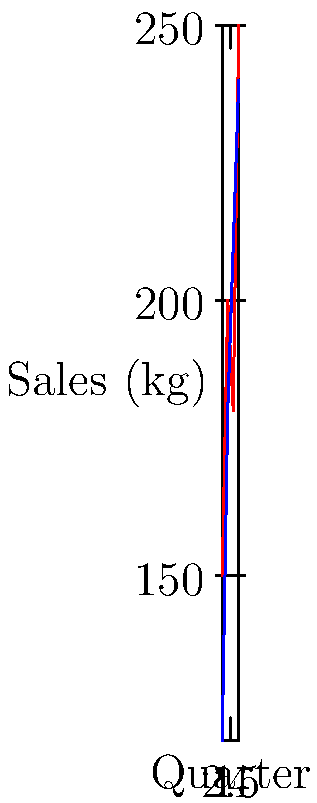Based on the coordinate plane showing quarterly sales data for Arabica and Robusta coffee beans, what is the total increase in sales (in kg) for Arabica beans from Q1 to Q4? To find the total increase in sales for Arabica beans from Q1 to Q4, we need to:

1. Identify the sales figures for Arabica in Q1 and Q4:
   Q1 (x = 1): 150 kg
   Q4 (x = 4): 250 kg

2. Calculate the difference between Q4 and Q1 sales:
   Increase = Q4 sales - Q1 sales
   Increase = 250 kg - 150 kg = 100 kg

Therefore, the total increase in sales for Arabica beans from Q1 to Q4 is 100 kg.
Answer: 100 kg 